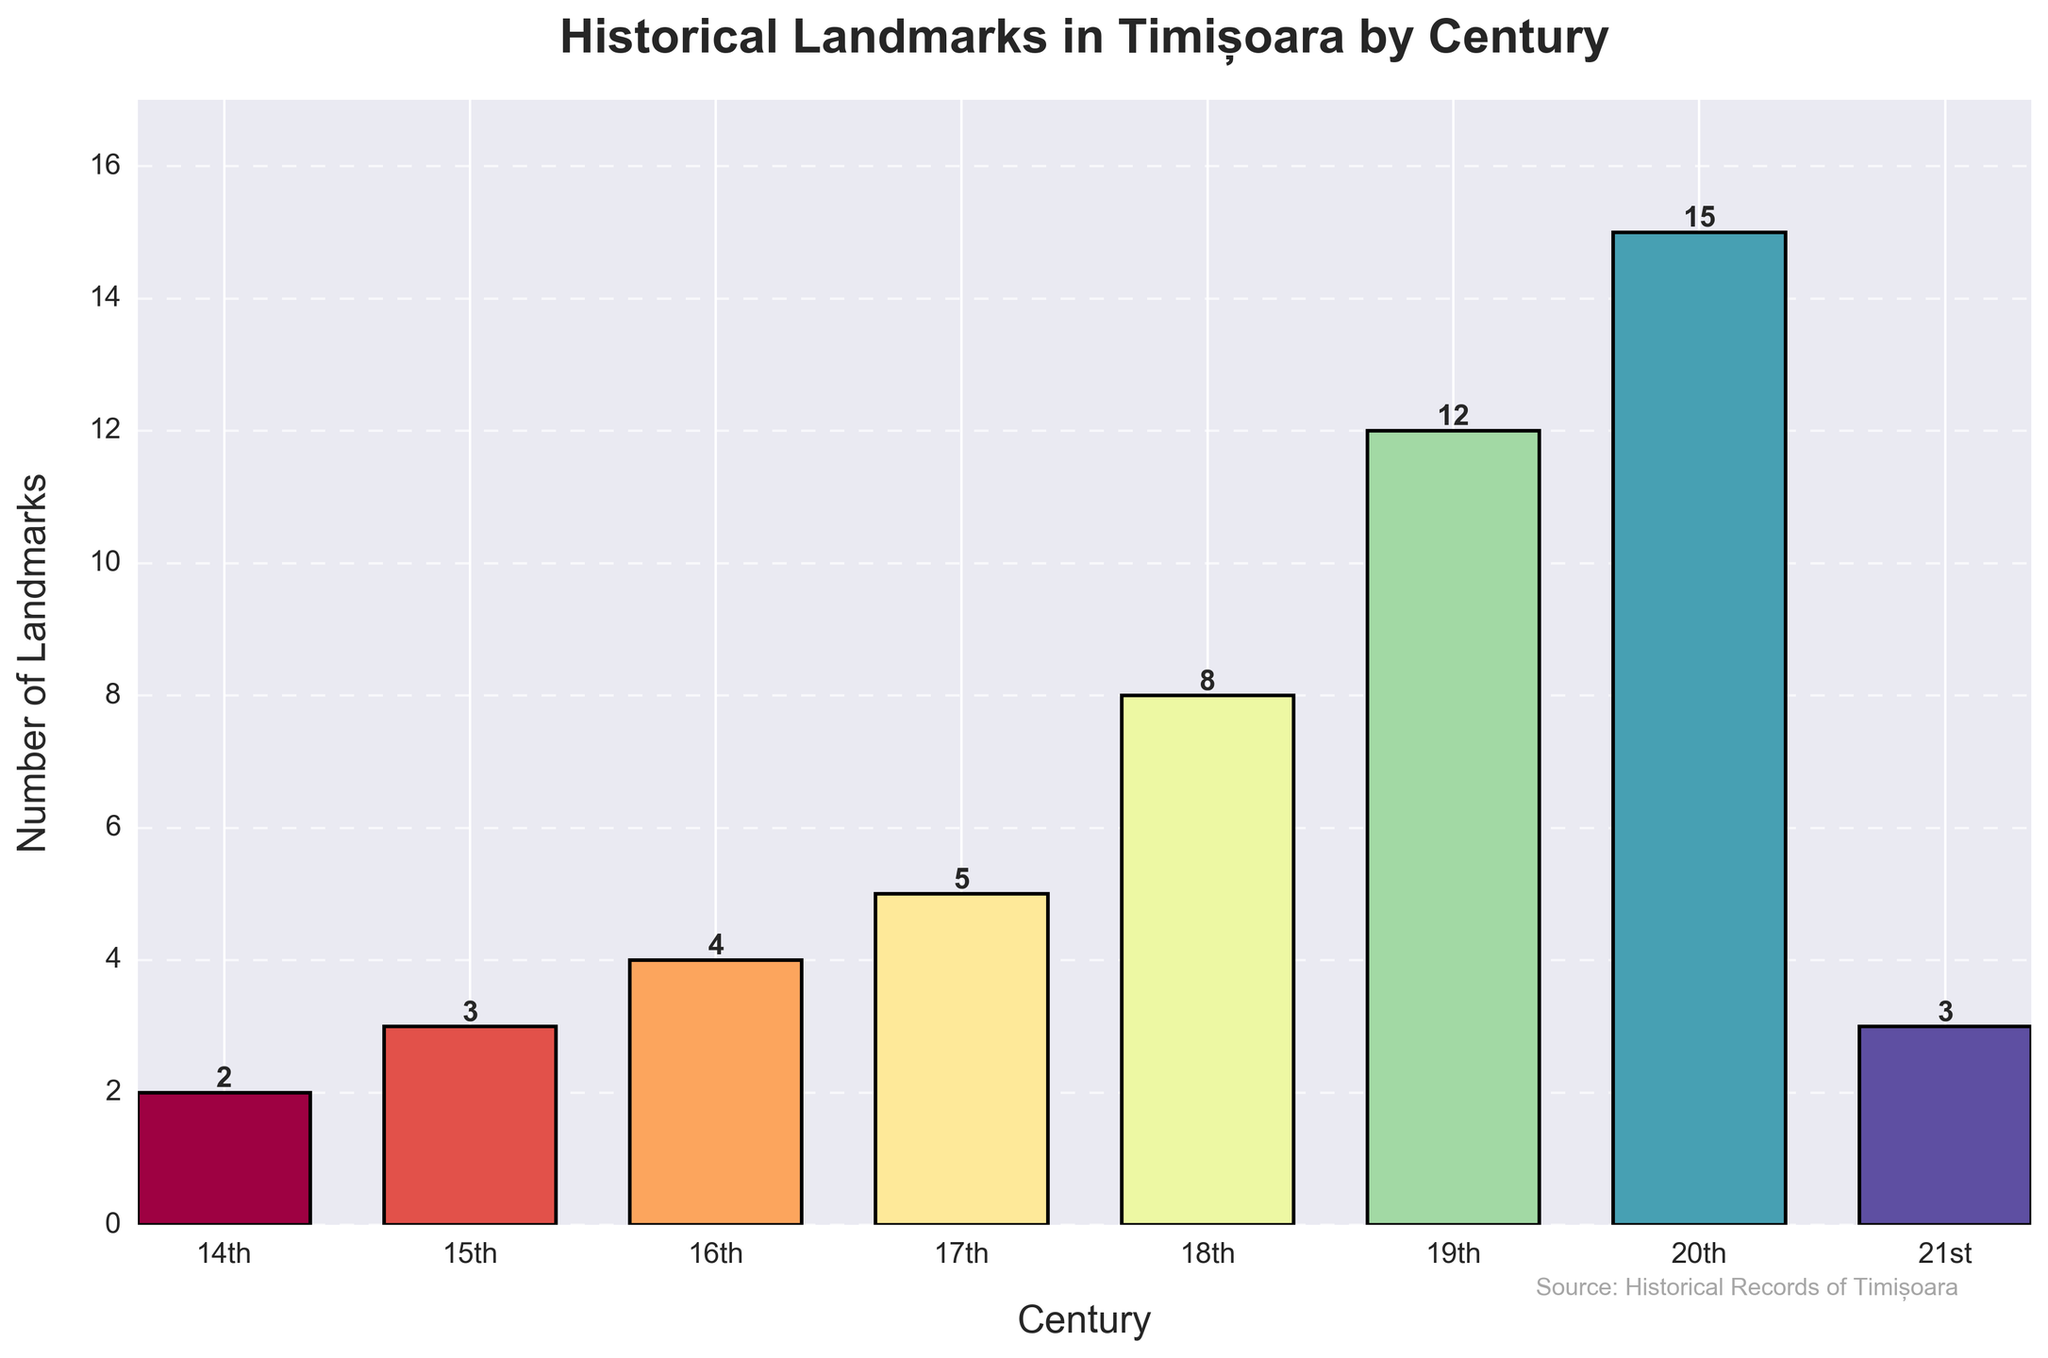What's the century with the highest number of historical landmarks in Timișoara? To find the century with the highest number of landmarks, observe the bars in the figure and identify the one with the greatest height. The 20th century bar is the tallest, indicating it has the highest count.
Answer: 20th century How many historical landmarks were constructed in the 18th and 19th centuries combined? Sum the number of landmarks for the 18th century (8) and the 19th century (12): 8 + 12 = 20.
Answer: 20 In which century did the number of historical landmarks increase the most compared to the previous century? Compare the difference in the number of landmarks for each century with its predecessor. The increase from the 18th to the 19th century (12 - 8 = 4) is the greatest.
Answer: From 18th to 19th century Which century has more historical landmarks, the 17th or the 21st century? Compare the height of the bars for the 17th (5 landmarks) and the 21st century (3 landmarks). The bar for the 17th century is taller.
Answer: 17th century What is the average number of historical landmarks per century for the 14th to 17th centuries? Calculate the average by summing the landmarks for the 14th (2), 15th (3), 16th (4), and 17th centuries (5), then dividing by 4: (2 + 3 + 4 + 5) / 4 = 3.5.
Answer: 3.5 Which century had exactly three historical landmarks? Identify the bar with a height of 3, which occurs in both the 15th and 21st centuries.
Answer: 15th and 21st centuries How many more landmarks are there in the 20th century compared to the 16th century? Subtract the number of 16th-century landmarks (4) from the 20th-century landmarks (15): 15 - 4 = 11.
Answer: 11 What is the trend in the number of historical landmarks from the 14th to the 20th century? Observe the pattern in the bar heights from the 14th to the 20th century. There is a general upward trend, indicating an increase in the number of landmarks over time.
Answer: Increasing trend 